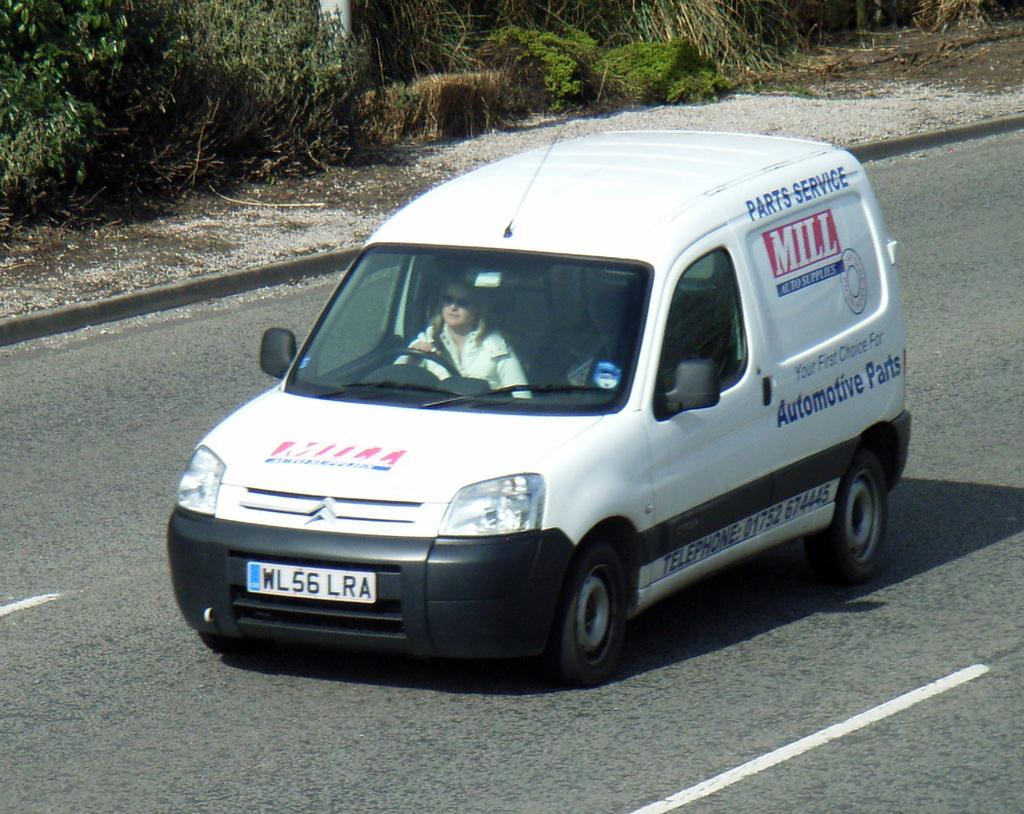What is the woman in the image doing? The woman is driving a car. What can be seen in the background of the image? The background of the image includes trees. How many balls are visible in the image? There are no balls present in the image. Is there a fan visible in the image? There is no fan present in the image. 